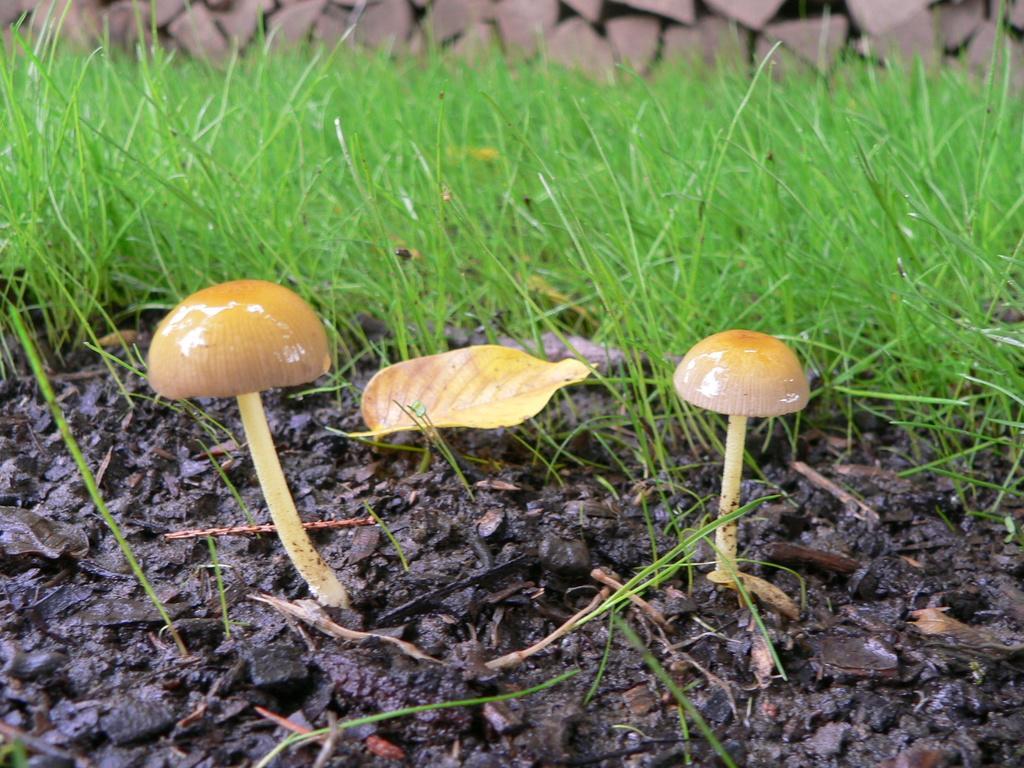How would you summarize this image in a sentence or two? In this image I can see two mushrooms and grass on the ground. At the top of the image there are some rocks. 